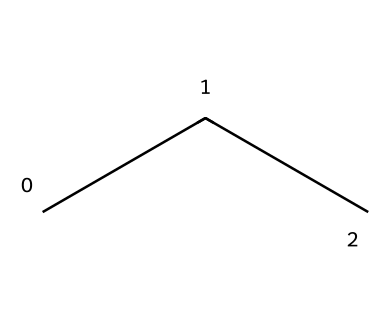What is the molecular formula of propane? The SMILES representation "CCC" indicates three carbon atoms (C) and eight hydrogen atoms (H). Thus, the molecular formula is derived by counting the atoms: C3H8.
Answer: C3H8 How many carbon atoms are present in propane? The SMILES notation "CCC" illustrates three carbon atoms connected in a chain. Counting the 'C's shows there are three carbon atoms.
Answer: 3 What type of bonds are present between carbon atoms in propane? The structure represented by "CCC" shows that each carbon is connected to the next with single bonds, indicated by the absence of any double or triple bond symbols. Therefore, the bonds between carbon atoms are single covalent bonds.
Answer: single bonds Is propane considered a saturated hydrocarbon? Propane is a hydrocarbon with single bonds only between carbon atoms, indicating it fully saturates with hydrogen, fulfilling the definition of a saturated hydrocarbon.
Answer: yes What are the typical uses of propane in food processing? Propane is primarily used as a refrigerant in small-scale food processing due to its favorable thermodynamic properties for cooling applications, including being environmentally friendly and effective.
Answer: refrigerant 